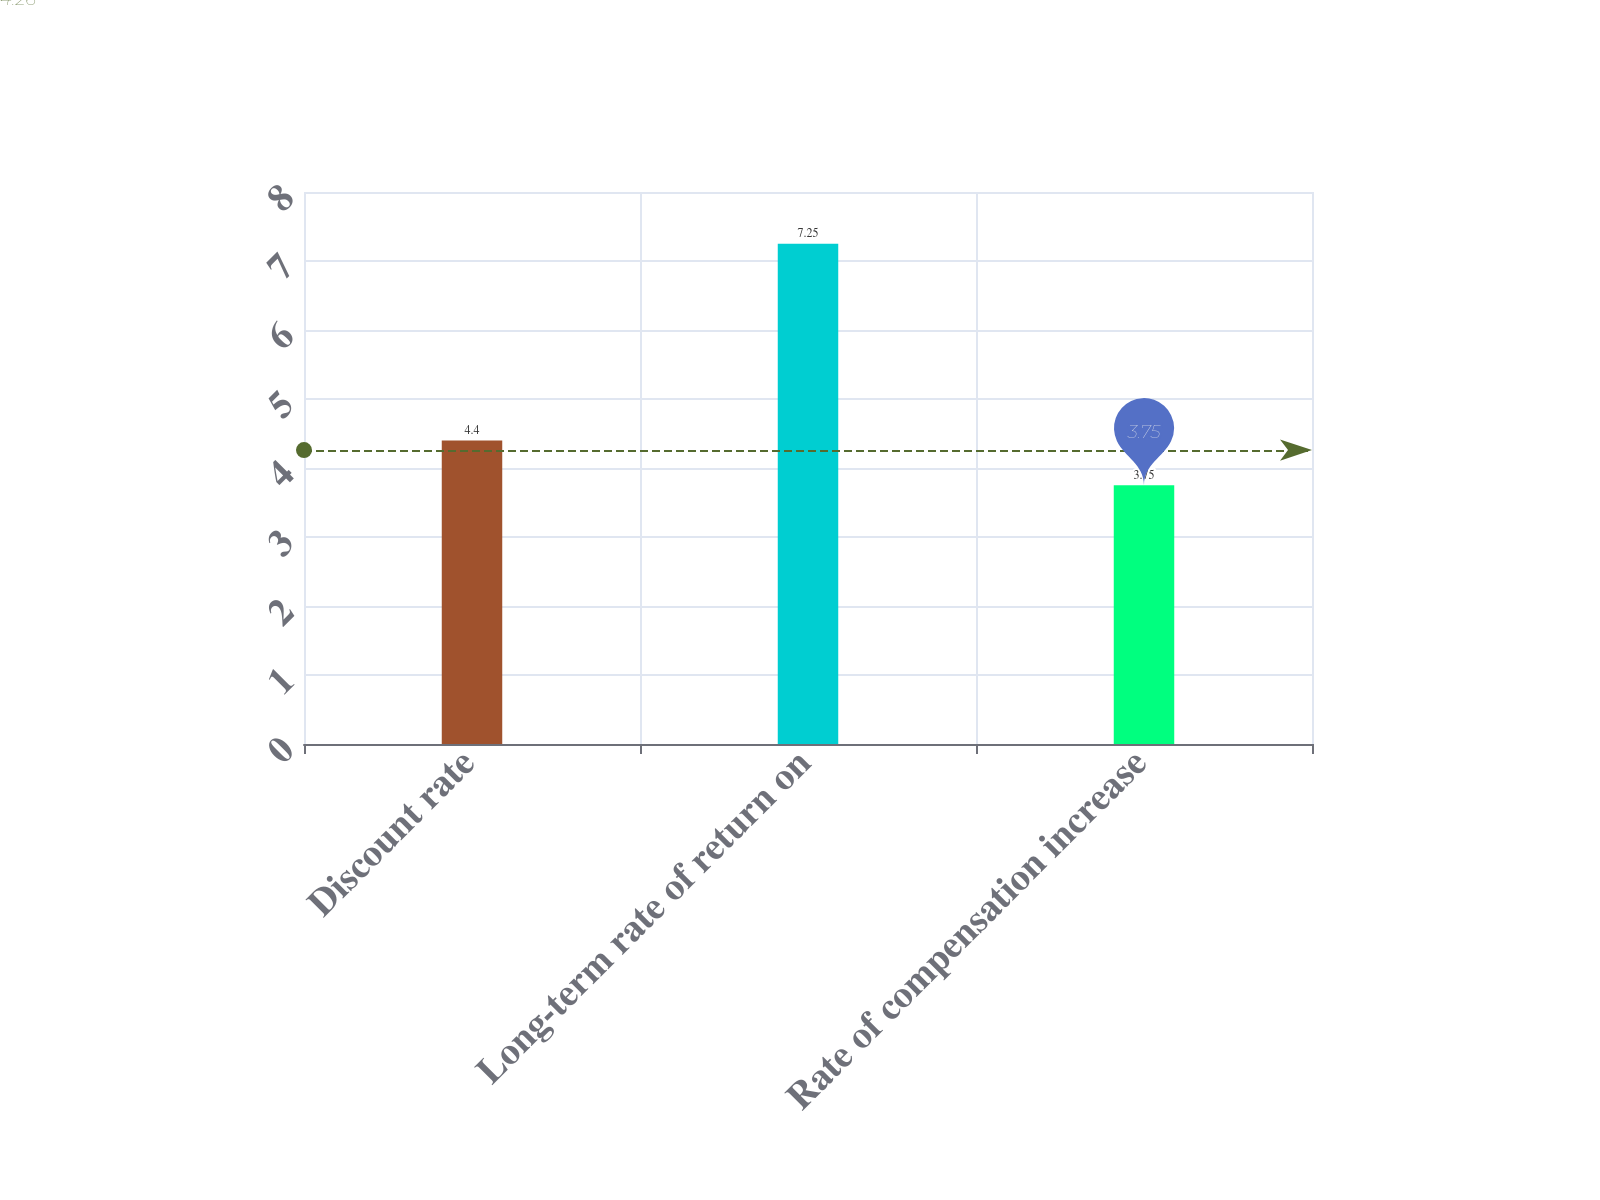<chart> <loc_0><loc_0><loc_500><loc_500><bar_chart><fcel>Discount rate<fcel>Long-term rate of return on<fcel>Rate of compensation increase<nl><fcel>4.4<fcel>7.25<fcel>3.75<nl></chart> 